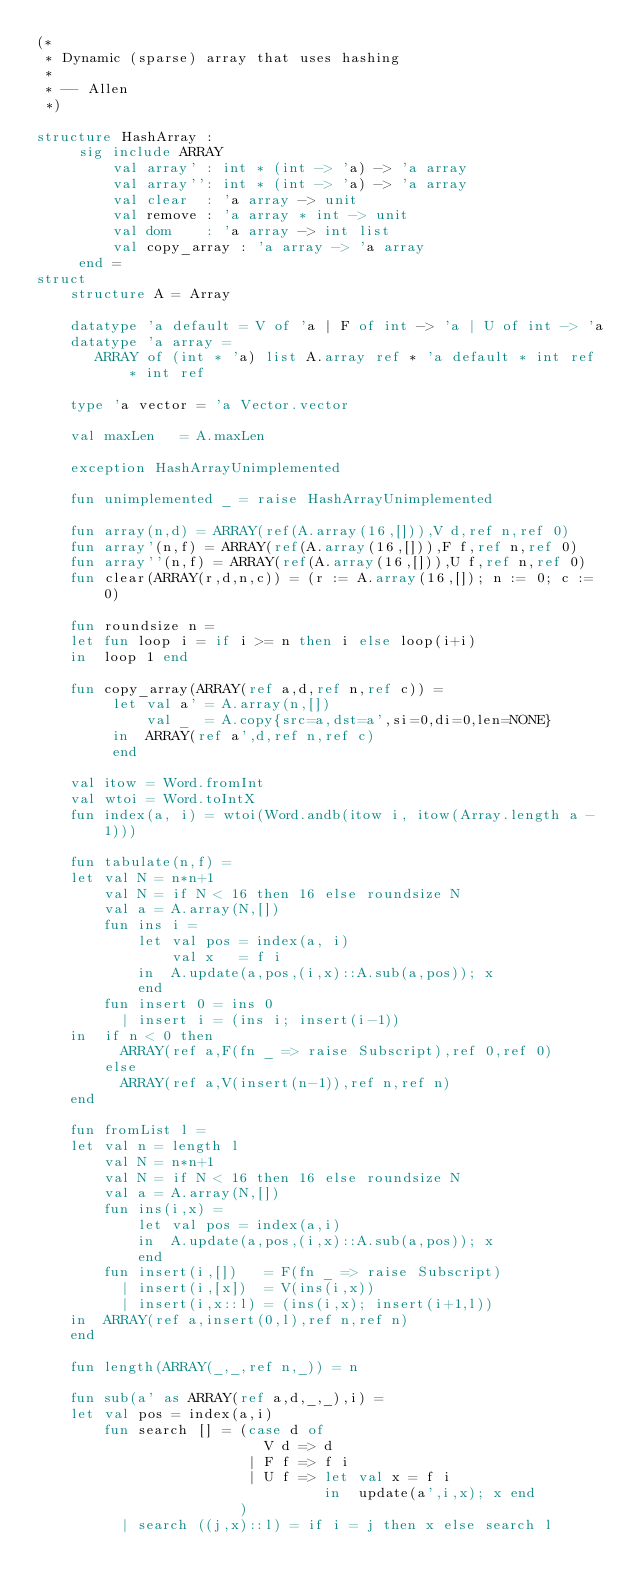Convert code to text. <code><loc_0><loc_0><loc_500><loc_500><_SML_>(*
 * Dynamic (sparse) array that uses hashing
 *
 * -- Allen
 *)

structure HashArray : 
     sig include ARRAY
         val array' : int * (int -> 'a) -> 'a array
         val array'': int * (int -> 'a) -> 'a array
         val clear  : 'a array -> unit 
         val remove : 'a array * int -> unit
         val dom    : 'a array -> int list
         val copy_array : 'a array -> 'a array
     end =
struct
    structure A = Array

    datatype 'a default = V of 'a | F of int -> 'a | U of int -> 'a
    datatype 'a array = 
       ARRAY of (int * 'a) list A.array ref * 'a default * int ref * int ref

    type 'a vector = 'a Vector.vector

    val maxLen   = A.maxLen

    exception HashArrayUnimplemented

    fun unimplemented _ = raise HashArrayUnimplemented

    fun array(n,d) = ARRAY(ref(A.array(16,[])),V d,ref n,ref 0)
    fun array'(n,f) = ARRAY(ref(A.array(16,[])),F f,ref n,ref 0)
    fun array''(n,f) = ARRAY(ref(A.array(16,[])),U f,ref n,ref 0)
    fun clear(ARRAY(r,d,n,c)) = (r := A.array(16,[]); n := 0; c := 0)

    fun roundsize n =
    let fun loop i = if i >= n then i else loop(i+i)
    in  loop 1 end 

    fun copy_array(ARRAY(ref a,d,ref n,ref c)) = 
         let val a' = A.array(n,[])
             val _  = A.copy{src=a,dst=a',si=0,di=0,len=NONE}
         in  ARRAY(ref a',d,ref n,ref c)
         end

    val itow = Word.fromInt
    val wtoi = Word.toIntX
    fun index(a, i) = wtoi(Word.andb(itow i, itow(Array.length a - 1)))

    fun tabulate(n,f) =
    let val N = n*n+1
        val N = if N < 16 then 16 else roundsize N
        val a = A.array(N,[])
        fun ins i = 
            let val pos = index(a, i)
                val x   = f i
            in  A.update(a,pos,(i,x)::A.sub(a,pos)); x
            end
        fun insert 0 = ins 0
          | insert i = (ins i; insert(i-1))
    in  if n < 0 then
          ARRAY(ref a,F(fn _ => raise Subscript),ref 0,ref 0)
        else
          ARRAY(ref a,V(insert(n-1)),ref n,ref n)
    end

    fun fromList l =
    let val n = length l
        val N = n*n+1
        val N = if N < 16 then 16 else roundsize N
        val a = A.array(N,[])
        fun ins(i,x) = 
            let val pos = index(a,i)
            in  A.update(a,pos,(i,x)::A.sub(a,pos)); x
            end
        fun insert(i,[])   = F(fn _ => raise Subscript)
          | insert(i,[x])  = V(ins(i,x))
          | insert(i,x::l) = (ins(i,x); insert(i+1,l))
    in  ARRAY(ref a,insert(0,l),ref n,ref n)
    end

    fun length(ARRAY(_,_,ref n,_)) = n

    fun sub(a' as ARRAY(ref a,d,_,_),i) = 
    let val pos = index(a,i)
        fun search [] = (case d of
                           V d => d
                         | F f => f i
                         | U f => let val x = f i
                                  in  update(a',i,x); x end
                        )
          | search ((j,x)::l) = if i = j then x else search l</code> 